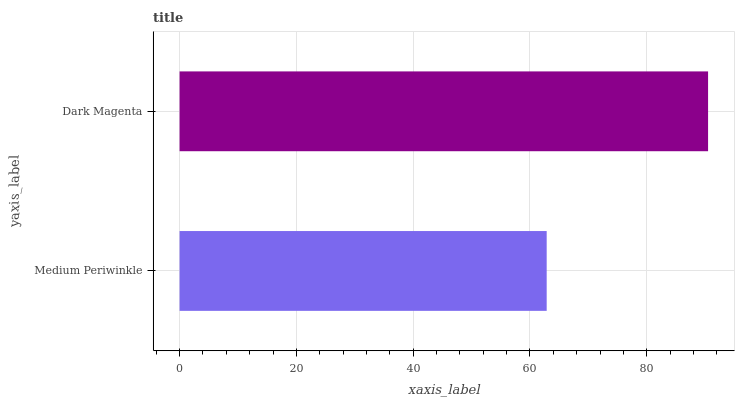Is Medium Periwinkle the minimum?
Answer yes or no. Yes. Is Dark Magenta the maximum?
Answer yes or no. Yes. Is Dark Magenta the minimum?
Answer yes or no. No. Is Dark Magenta greater than Medium Periwinkle?
Answer yes or no. Yes. Is Medium Periwinkle less than Dark Magenta?
Answer yes or no. Yes. Is Medium Periwinkle greater than Dark Magenta?
Answer yes or no. No. Is Dark Magenta less than Medium Periwinkle?
Answer yes or no. No. Is Dark Magenta the high median?
Answer yes or no. Yes. Is Medium Periwinkle the low median?
Answer yes or no. Yes. Is Medium Periwinkle the high median?
Answer yes or no. No. Is Dark Magenta the low median?
Answer yes or no. No. 